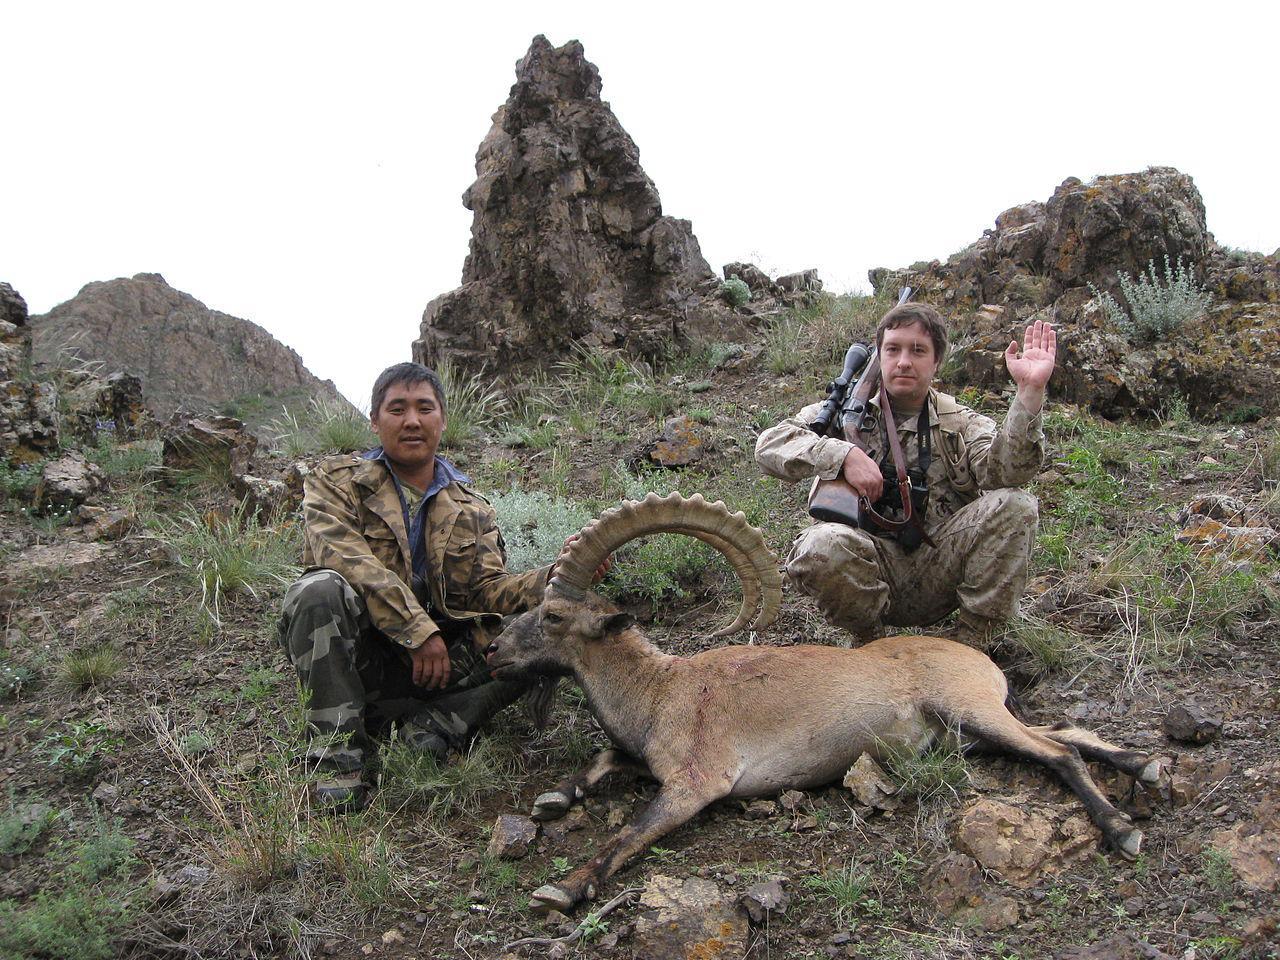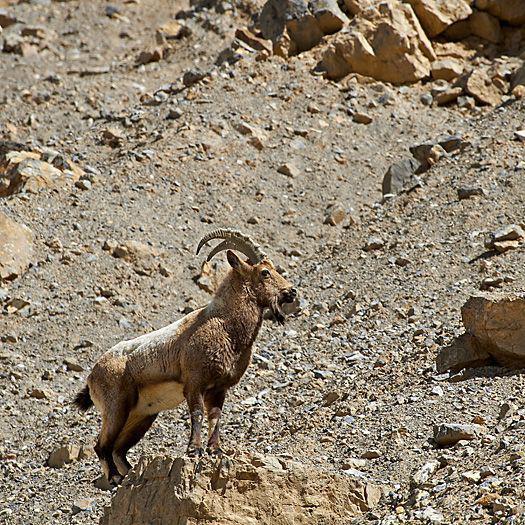The first image is the image on the left, the second image is the image on the right. Given the left and right images, does the statement "Right and left images contain the same number of hooved animals." hold true? Answer yes or no. Yes. The first image is the image on the left, the second image is the image on the right. Examine the images to the left and right. Is the description "The rams are walking on green grass in the image on the left." accurate? Answer yes or no. No. 